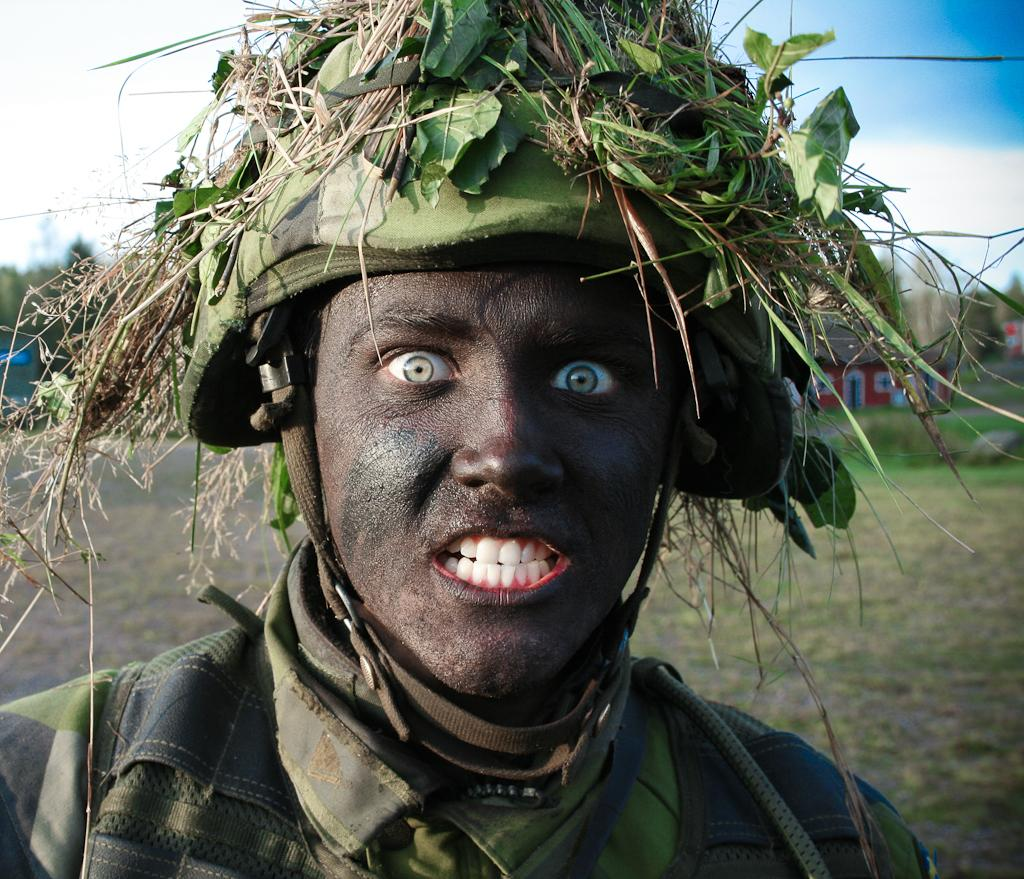Who or what is the main subject of the image? There is a person in the image. What is the person wearing on their head? The person is wearing a cap. Are there any additional objects or elements on the person's head? Yes, there are leaves on the person's head. What can be seen in the background of the image? The sky is visible in the background of the image. What suggestions does the person in the image have for improving the town's infrastructure? There is no indication in the image that the person is making any suggestions about the town's infrastructure. Is the person in the image writing anything down? There is no indication in the image that the person is writing anything down. 